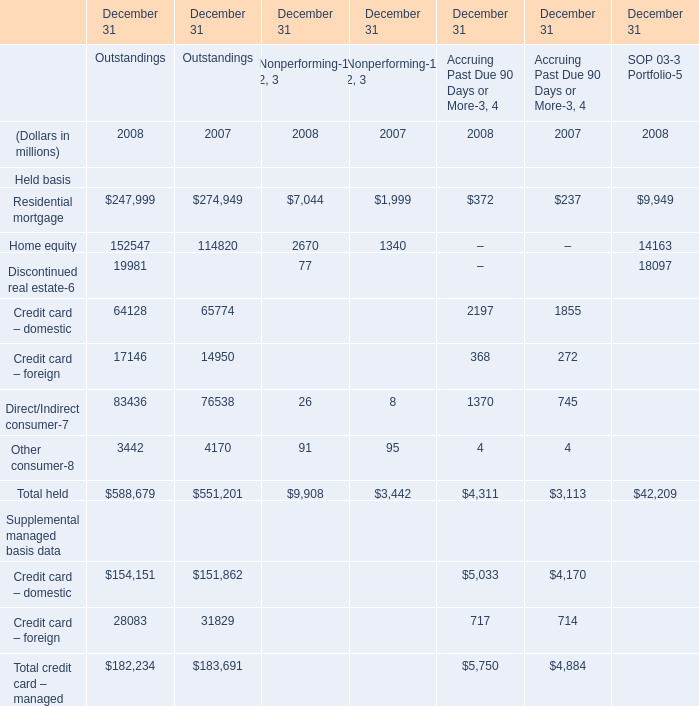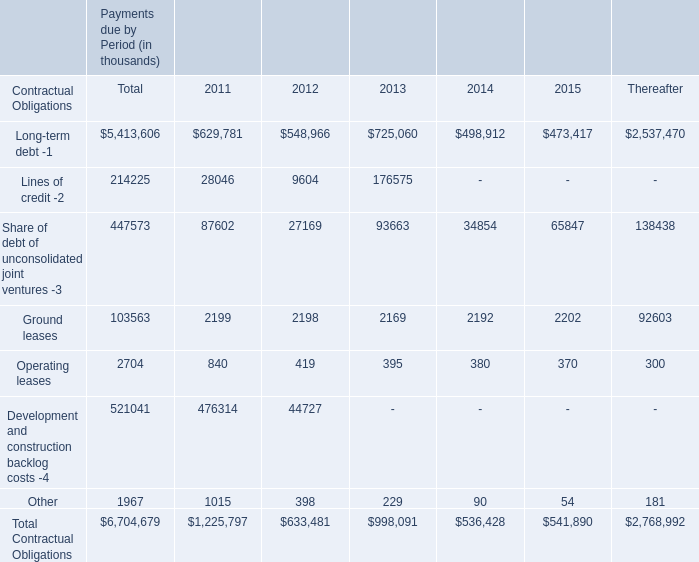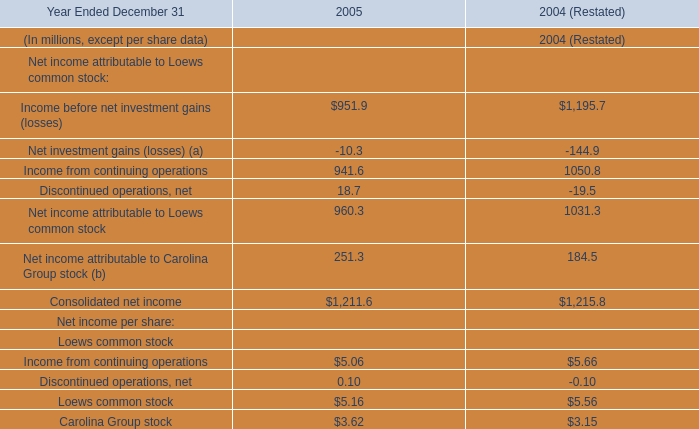What is the difference between the greatest Residential mortgage in 2008 and 2007? (in million) 
Computations: (247999 - 274949)
Answer: -26950.0. 